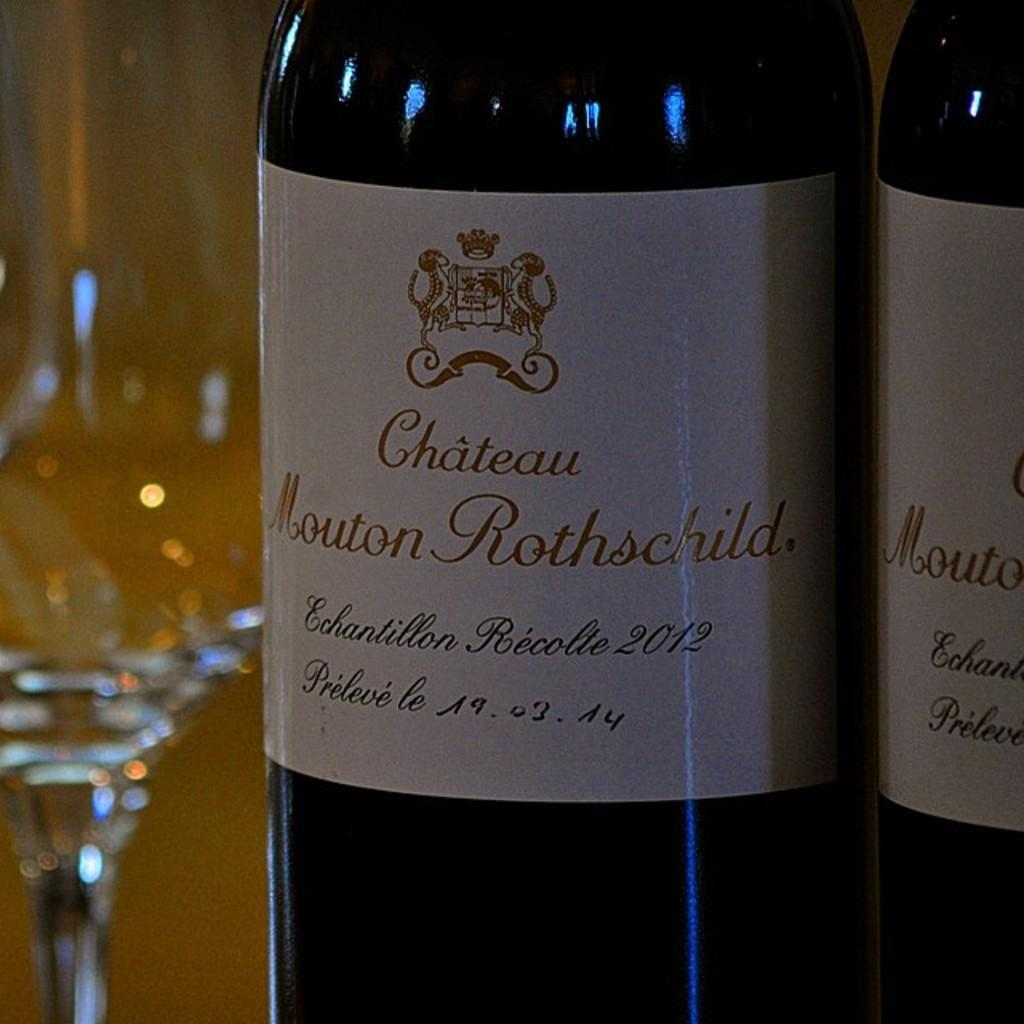<image>
Render a clear and concise summary of the photo. A bottle of Chateau Mouton Rothschild was bottled in 2012. 